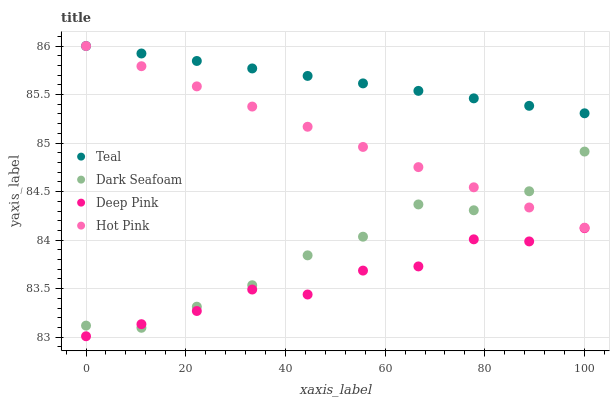Does Deep Pink have the minimum area under the curve?
Answer yes or no. Yes. Does Teal have the maximum area under the curve?
Answer yes or no. Yes. Does Teal have the minimum area under the curve?
Answer yes or no. No. Does Deep Pink have the maximum area under the curve?
Answer yes or no. No. Is Hot Pink the smoothest?
Answer yes or no. Yes. Is Deep Pink the roughest?
Answer yes or no. Yes. Is Teal the smoothest?
Answer yes or no. No. Is Teal the roughest?
Answer yes or no. No. Does Deep Pink have the lowest value?
Answer yes or no. Yes. Does Teal have the lowest value?
Answer yes or no. No. Does Hot Pink have the highest value?
Answer yes or no. Yes. Does Deep Pink have the highest value?
Answer yes or no. No. Is Deep Pink less than Teal?
Answer yes or no. Yes. Is Teal greater than Dark Seafoam?
Answer yes or no. Yes. Does Dark Seafoam intersect Deep Pink?
Answer yes or no. Yes. Is Dark Seafoam less than Deep Pink?
Answer yes or no. No. Is Dark Seafoam greater than Deep Pink?
Answer yes or no. No. Does Deep Pink intersect Teal?
Answer yes or no. No. 